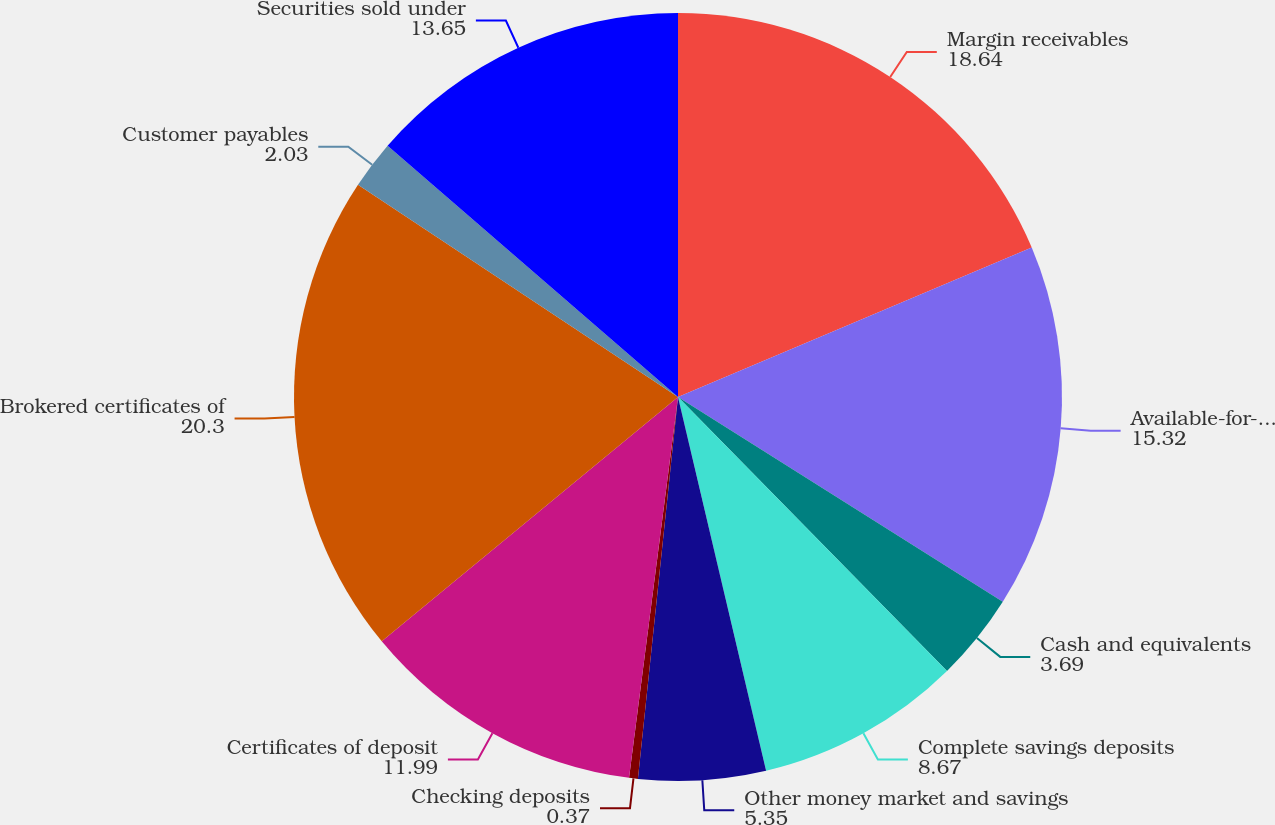Convert chart. <chart><loc_0><loc_0><loc_500><loc_500><pie_chart><fcel>Margin receivables<fcel>Available-for-sale securities<fcel>Cash and equivalents<fcel>Complete savings deposits<fcel>Other money market and savings<fcel>Checking deposits<fcel>Certificates of deposit<fcel>Brokered certificates of<fcel>Customer payables<fcel>Securities sold under<nl><fcel>18.64%<fcel>15.32%<fcel>3.69%<fcel>8.67%<fcel>5.35%<fcel>0.37%<fcel>11.99%<fcel>20.3%<fcel>2.03%<fcel>13.65%<nl></chart> 